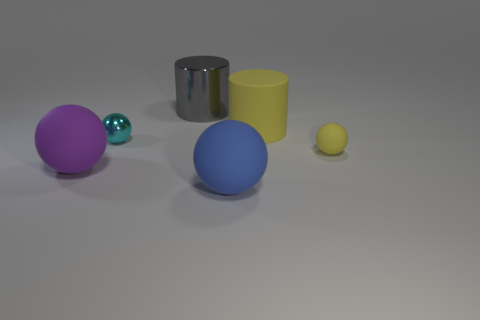Does the rubber ball to the right of the blue rubber sphere have the same color as the big matte cylinder?
Give a very brief answer. Yes. How many objects are big metal cylinders or large yellow matte cylinders?
Keep it short and to the point. 2. Is the size of the yellow matte thing in front of the yellow cylinder the same as the rubber cylinder?
Make the answer very short. No. There is a ball that is behind the large purple matte object and to the right of the big shiny cylinder; what is its size?
Your answer should be compact. Small. What number of other objects are there of the same shape as the large yellow object?
Provide a short and direct response. 1. What number of other things are the same material as the blue object?
Ensure brevity in your answer.  3. What size is the purple matte object that is the same shape as the tiny cyan shiny object?
Make the answer very short. Large. Do the rubber cylinder and the tiny matte thing have the same color?
Provide a short and direct response. Yes. There is a large object that is on the right side of the big shiny object and behind the tiny metal object; what is its color?
Give a very brief answer. Yellow. What number of objects are either large matte balls on the right side of the big gray thing or tiny gray shiny objects?
Offer a very short reply. 1. 